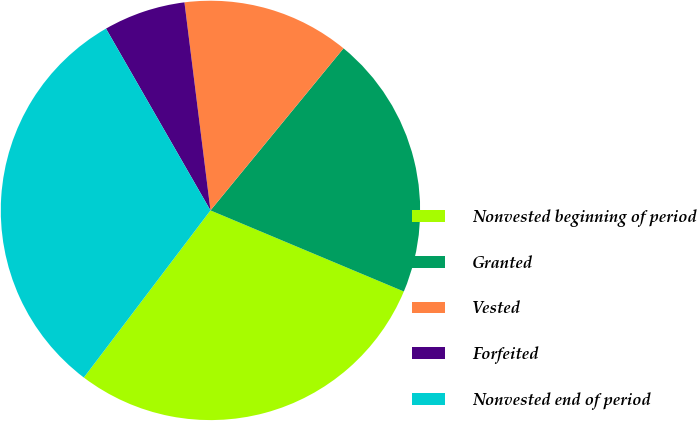<chart> <loc_0><loc_0><loc_500><loc_500><pie_chart><fcel>Nonvested beginning of period<fcel>Granted<fcel>Vested<fcel>Forfeited<fcel>Nonvested end of period<nl><fcel>29.0%<fcel>20.38%<fcel>12.92%<fcel>6.32%<fcel>31.38%<nl></chart> 